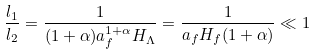<formula> <loc_0><loc_0><loc_500><loc_500>\frac { l _ { 1 } } { l _ { 2 } } = \frac { 1 } { ( 1 + \alpha ) a _ { f } ^ { 1 + \alpha } H _ { \Lambda } } = \frac { 1 } { a _ { f } H _ { f } ( 1 + \alpha ) } \ll 1</formula> 